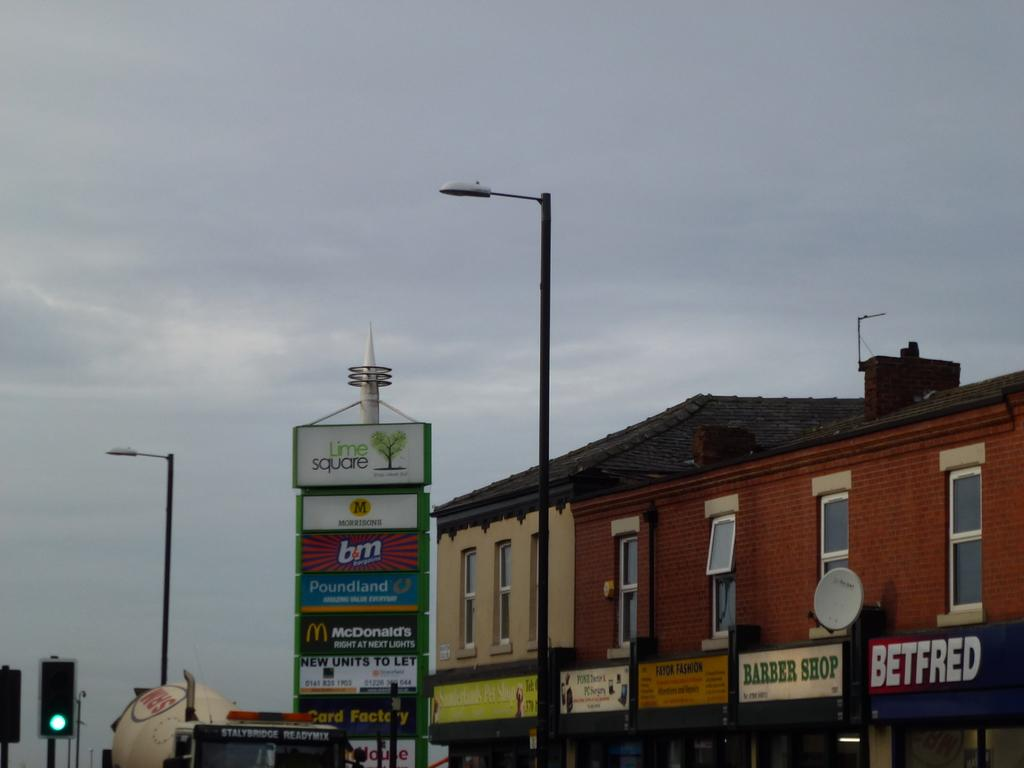<image>
Write a terse but informative summary of the picture. A row of business establishments include places like a barber shop, a computer repair store and a betting center. 